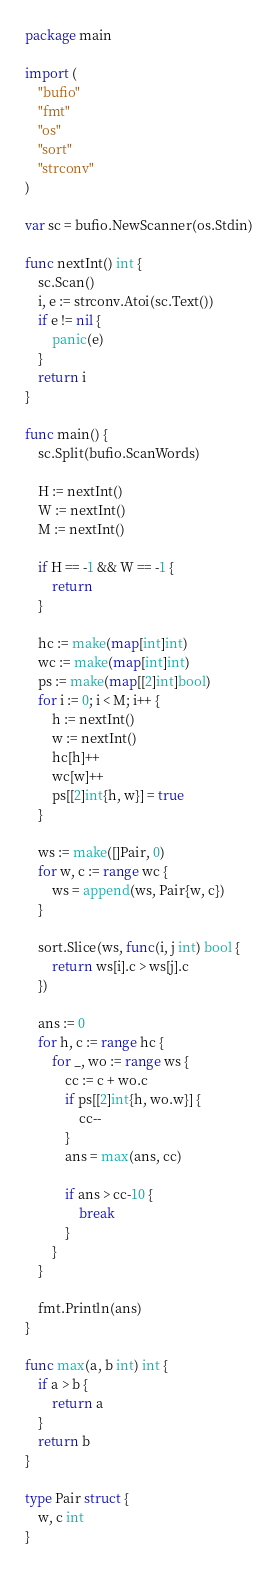<code> <loc_0><loc_0><loc_500><loc_500><_Go_>package main

import (
	"bufio"
	"fmt"
	"os"
	"sort"
	"strconv"
)

var sc = bufio.NewScanner(os.Stdin)

func nextInt() int {
	sc.Scan()
	i, e := strconv.Atoi(sc.Text())
	if e != nil {
		panic(e)
	}
	return i
}

func main() {
	sc.Split(bufio.ScanWords)

	H := nextInt()
	W := nextInt()
	M := nextInt()

	if H == -1 && W == -1 {
		return
	}

	hc := make(map[int]int)
	wc := make(map[int]int)
	ps := make(map[[2]int]bool)
	for i := 0; i < M; i++ {
		h := nextInt()
		w := nextInt()
		hc[h]++
		wc[w]++
		ps[[2]int{h, w}] = true
	}

	ws := make([]Pair, 0)
	for w, c := range wc {
		ws = append(ws, Pair{w, c})
	}

	sort.Slice(ws, func(i, j int) bool {
		return ws[i].c > ws[j].c
	})

	ans := 0
	for h, c := range hc {
		for _, wo := range ws {
			cc := c + wo.c
			if ps[[2]int{h, wo.w}] {
				cc--
			}
			ans = max(ans, cc)

			if ans > cc-10 {
				break
			}
		}
	}

	fmt.Println(ans)
}

func max(a, b int) int {
	if a > b {
		return a
	}
	return b
}

type Pair struct {
	w, c int
}
</code> 